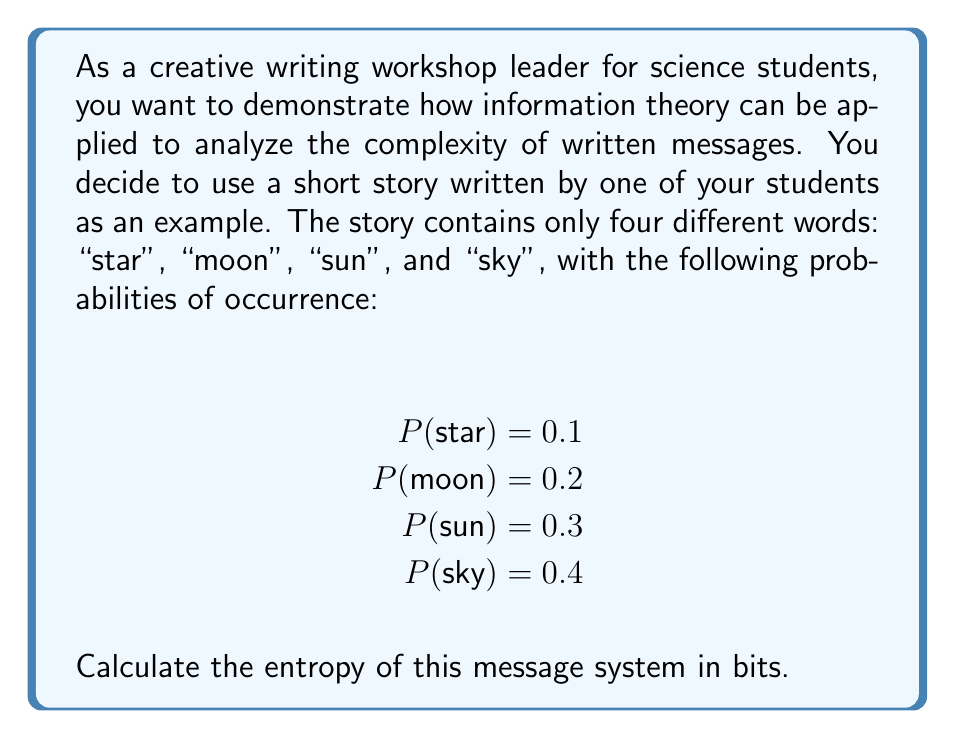Could you help me with this problem? To calculate the entropy of this message system, we'll use Shannon's entropy formula:

$$H = -\sum_{i=1}^n p_i \log_2(p_i)$$

Where:
$H$ is the entropy in bits
$p_i$ is the probability of each symbol (word in this case)
$n$ is the number of different symbols (words)

Let's calculate the entropy step by step:

1. For "star": $p_1 = 0.1$
   $-p_1 \log_2(p_1) = -0.1 \log_2(0.1) \approx 0.3322$

2. For "moon": $p_2 = 0.2$
   $-p_2 \log_2(p_2) = -0.2 \log_2(0.2) \approx 0.4644$

3. For "sun": $p_3 = 0.3$
   $-p_3 \log_2(p_3) = -0.3 \log_2(0.3) \approx 0.5210$

4. For "sky": $p_4 = 0.4$
   $-p_4 \log_2(p_4) = -0.4 \log_2(0.4) \approx 0.5288$

Now, we sum up all these values:

$$H = 0.3322 + 0.4644 + 0.5210 + 0.5288 \approx 1.8464$$

Therefore, the entropy of this message system is approximately 1.8464 bits.
Answer: The entropy of the message system is approximately 1.8464 bits. 